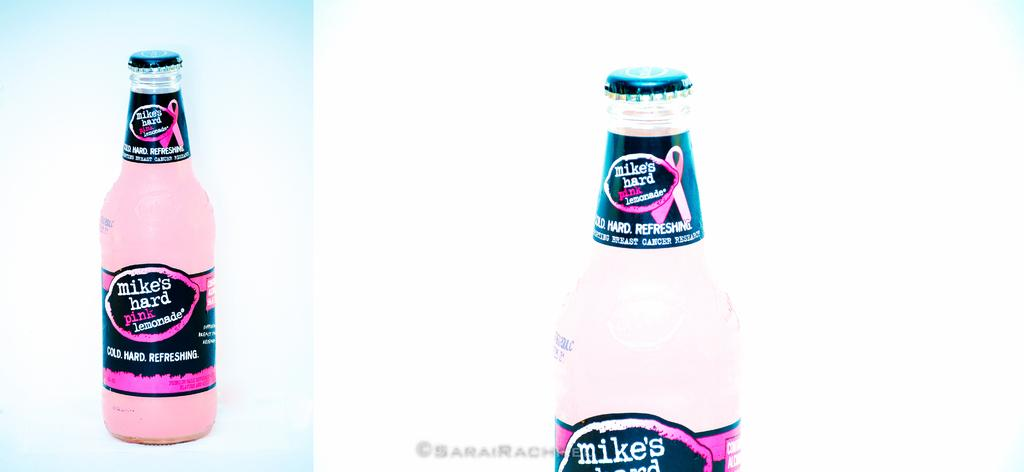How many bottles are visible in the image? There are two bottles in the image. What type of card is being used to drink from the bottles in the image? There is no card present in the image, and the bottles do not require a card to drink from. 